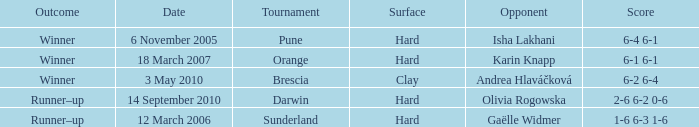When was the tournament at Orange? 18 March 2007. 